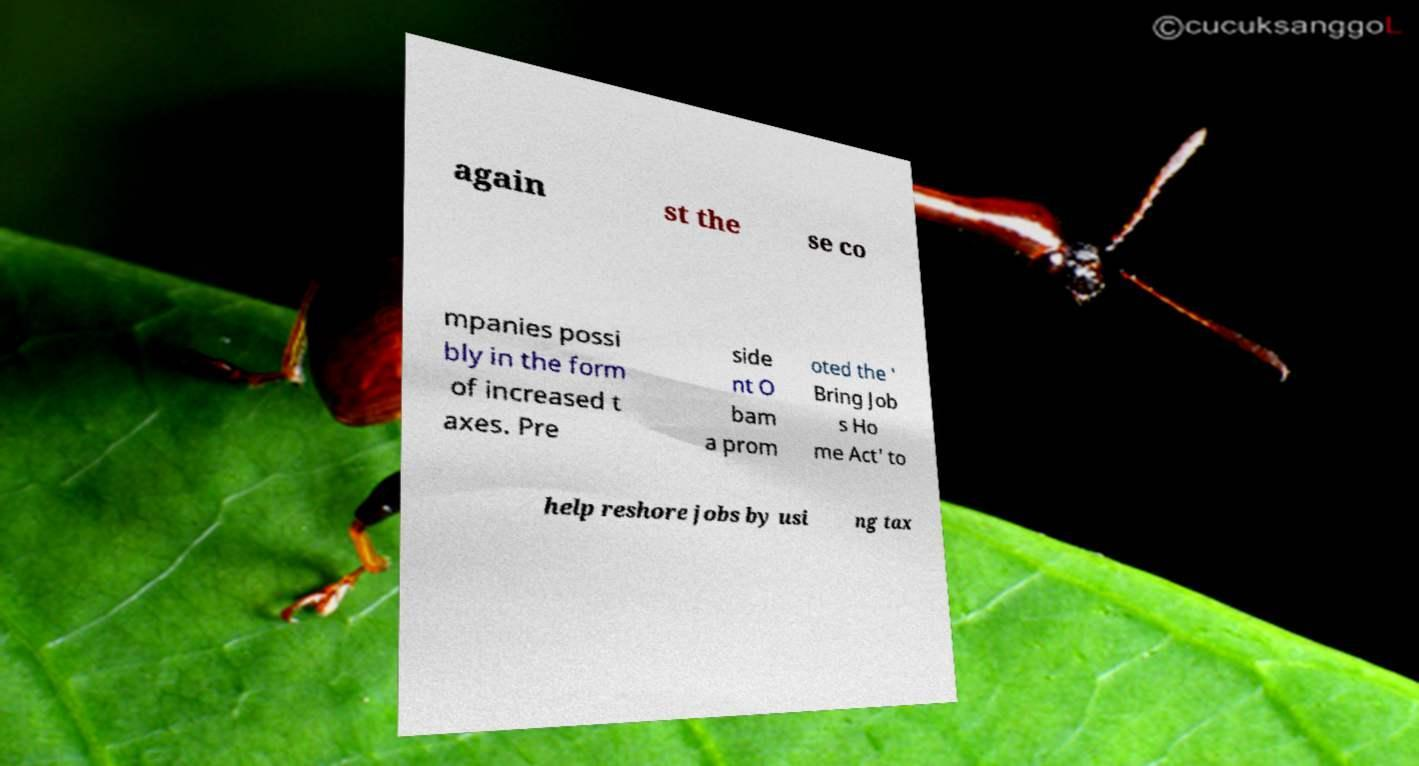Can you read and provide the text displayed in the image?This photo seems to have some interesting text. Can you extract and type it out for me? again st the se co mpanies possi bly in the form of increased t axes. Pre side nt O bam a prom oted the ' Bring Job s Ho me Act' to help reshore jobs by usi ng tax 